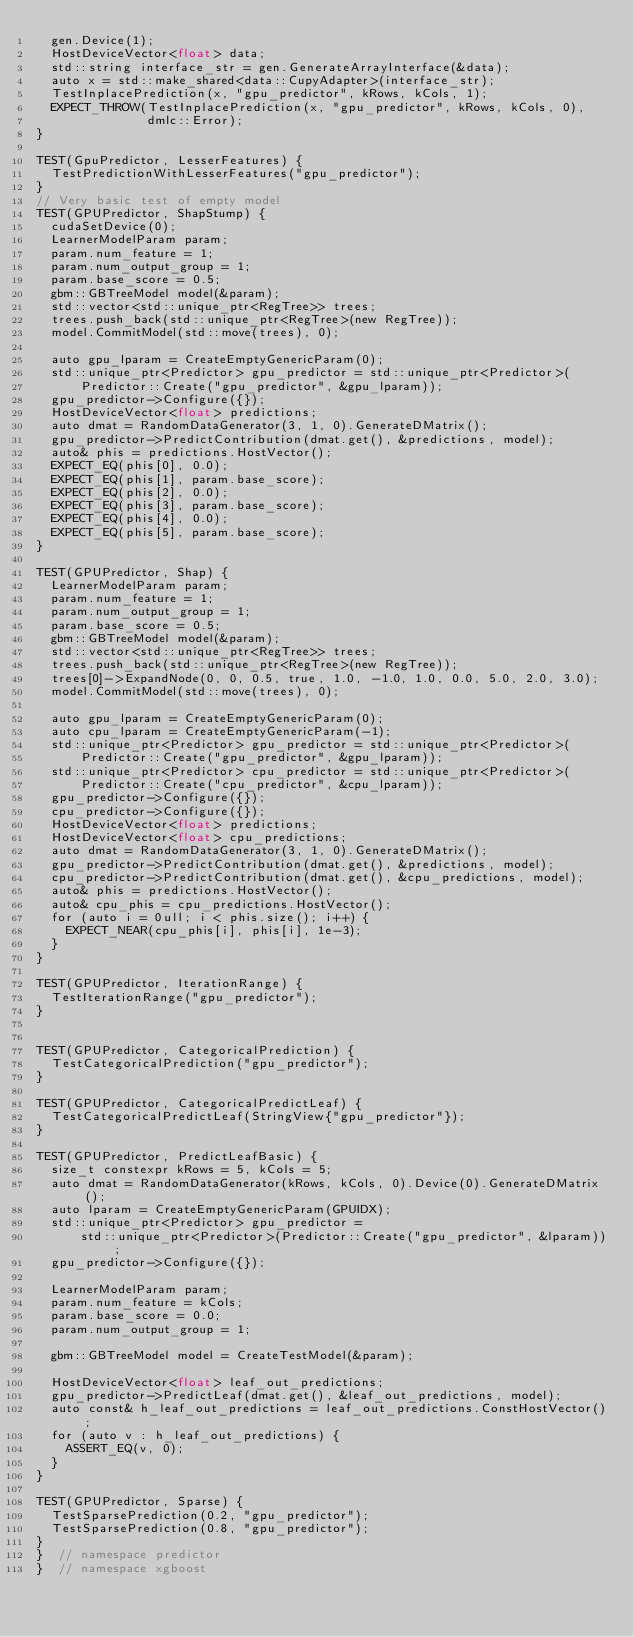<code> <loc_0><loc_0><loc_500><loc_500><_Cuda_>  gen.Device(1);
  HostDeviceVector<float> data;
  std::string interface_str = gen.GenerateArrayInterface(&data);
  auto x = std::make_shared<data::CupyAdapter>(interface_str);
  TestInplacePrediction(x, "gpu_predictor", kRows, kCols, 1);
  EXPECT_THROW(TestInplacePrediction(x, "gpu_predictor", kRows, kCols, 0),
               dmlc::Error);
}

TEST(GpuPredictor, LesserFeatures) {
  TestPredictionWithLesserFeatures("gpu_predictor");
}
// Very basic test of empty model
TEST(GPUPredictor, ShapStump) {
  cudaSetDevice(0);
  LearnerModelParam param;
  param.num_feature = 1;
  param.num_output_group = 1;
  param.base_score = 0.5;
  gbm::GBTreeModel model(&param);
  std::vector<std::unique_ptr<RegTree>> trees;
  trees.push_back(std::unique_ptr<RegTree>(new RegTree));
  model.CommitModel(std::move(trees), 0);

  auto gpu_lparam = CreateEmptyGenericParam(0);
  std::unique_ptr<Predictor> gpu_predictor = std::unique_ptr<Predictor>(
      Predictor::Create("gpu_predictor", &gpu_lparam));
  gpu_predictor->Configure({});
  HostDeviceVector<float> predictions;
  auto dmat = RandomDataGenerator(3, 1, 0).GenerateDMatrix();
  gpu_predictor->PredictContribution(dmat.get(), &predictions, model);
  auto& phis = predictions.HostVector();
  EXPECT_EQ(phis[0], 0.0);
  EXPECT_EQ(phis[1], param.base_score);
  EXPECT_EQ(phis[2], 0.0);
  EXPECT_EQ(phis[3], param.base_score);
  EXPECT_EQ(phis[4], 0.0);
  EXPECT_EQ(phis[5], param.base_score);
}

TEST(GPUPredictor, Shap) {
  LearnerModelParam param;
  param.num_feature = 1;
  param.num_output_group = 1;
  param.base_score = 0.5;
  gbm::GBTreeModel model(&param);
  std::vector<std::unique_ptr<RegTree>> trees;
  trees.push_back(std::unique_ptr<RegTree>(new RegTree));
  trees[0]->ExpandNode(0, 0, 0.5, true, 1.0, -1.0, 1.0, 0.0, 5.0, 2.0, 3.0);
  model.CommitModel(std::move(trees), 0);

  auto gpu_lparam = CreateEmptyGenericParam(0);
  auto cpu_lparam = CreateEmptyGenericParam(-1);
  std::unique_ptr<Predictor> gpu_predictor = std::unique_ptr<Predictor>(
      Predictor::Create("gpu_predictor", &gpu_lparam));
  std::unique_ptr<Predictor> cpu_predictor = std::unique_ptr<Predictor>(
      Predictor::Create("cpu_predictor", &cpu_lparam));
  gpu_predictor->Configure({});
  cpu_predictor->Configure({});
  HostDeviceVector<float> predictions;
  HostDeviceVector<float> cpu_predictions;
  auto dmat = RandomDataGenerator(3, 1, 0).GenerateDMatrix();
  gpu_predictor->PredictContribution(dmat.get(), &predictions, model);
  cpu_predictor->PredictContribution(dmat.get(), &cpu_predictions, model);
  auto& phis = predictions.HostVector();
  auto& cpu_phis = cpu_predictions.HostVector();
  for (auto i = 0ull; i < phis.size(); i++) {
    EXPECT_NEAR(cpu_phis[i], phis[i], 1e-3);
  }
}

TEST(GPUPredictor, IterationRange) {
  TestIterationRange("gpu_predictor");
}


TEST(GPUPredictor, CategoricalPrediction) {
  TestCategoricalPrediction("gpu_predictor");
}

TEST(GPUPredictor, CategoricalPredictLeaf) {
  TestCategoricalPredictLeaf(StringView{"gpu_predictor"});
}

TEST(GPUPredictor, PredictLeafBasic) {
  size_t constexpr kRows = 5, kCols = 5;
  auto dmat = RandomDataGenerator(kRows, kCols, 0).Device(0).GenerateDMatrix();
  auto lparam = CreateEmptyGenericParam(GPUIDX);
  std::unique_ptr<Predictor> gpu_predictor =
      std::unique_ptr<Predictor>(Predictor::Create("gpu_predictor", &lparam));
  gpu_predictor->Configure({});

  LearnerModelParam param;
  param.num_feature = kCols;
  param.base_score = 0.0;
  param.num_output_group = 1;

  gbm::GBTreeModel model = CreateTestModel(&param);

  HostDeviceVector<float> leaf_out_predictions;
  gpu_predictor->PredictLeaf(dmat.get(), &leaf_out_predictions, model);
  auto const& h_leaf_out_predictions = leaf_out_predictions.ConstHostVector();
  for (auto v : h_leaf_out_predictions) {
    ASSERT_EQ(v, 0);
  }
}

TEST(GPUPredictor, Sparse) {
  TestSparsePrediction(0.2, "gpu_predictor");
  TestSparsePrediction(0.8, "gpu_predictor");
}
}  // namespace predictor
}  // namespace xgboost
</code> 